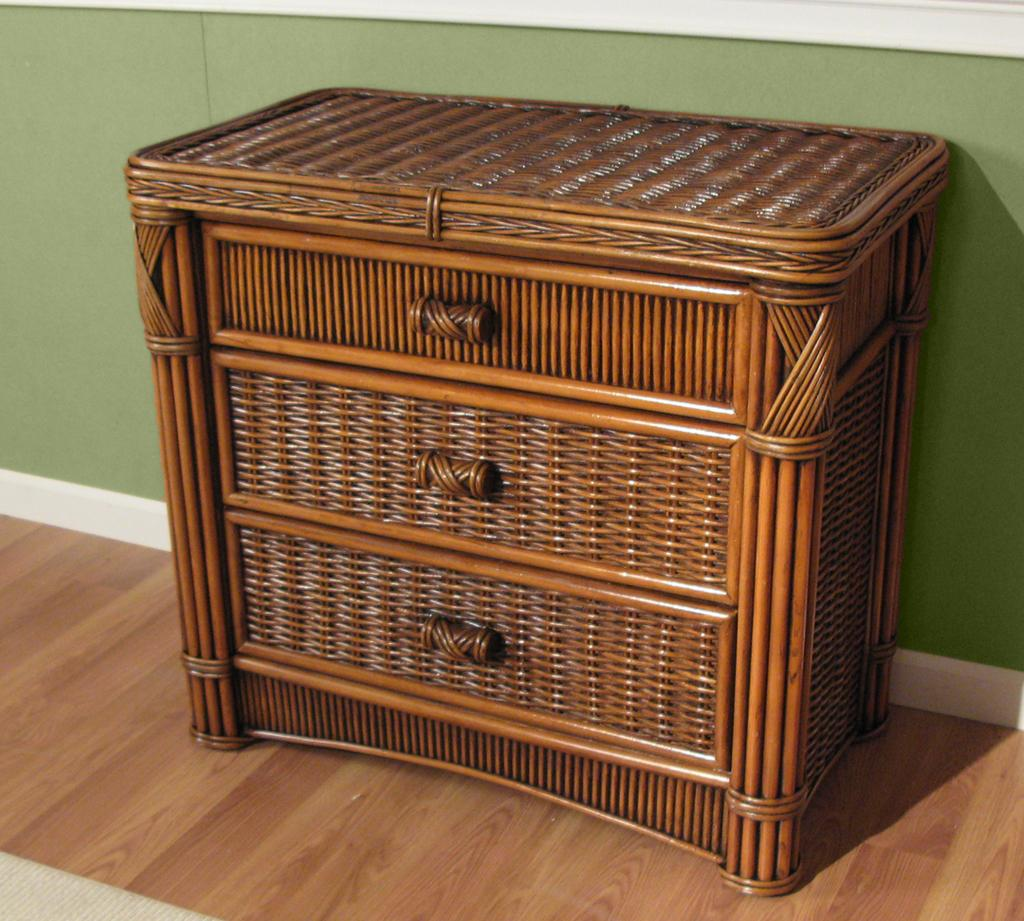What object is present in the image that has multiple compartments? There is a basket in the image that has racks. How can the basket be carried or moved? The basket has handles for carrying or moving it. Where is the basket located in the image? The basket is placed on the floor. What color is the wall visible in the background of the image? The wall in the background of the image is green. What type of addition problem can be solved using the numbers on the basket's racks? There are no numbers present on the basket's racks, so it is not possible to solve an addition problem using them. 